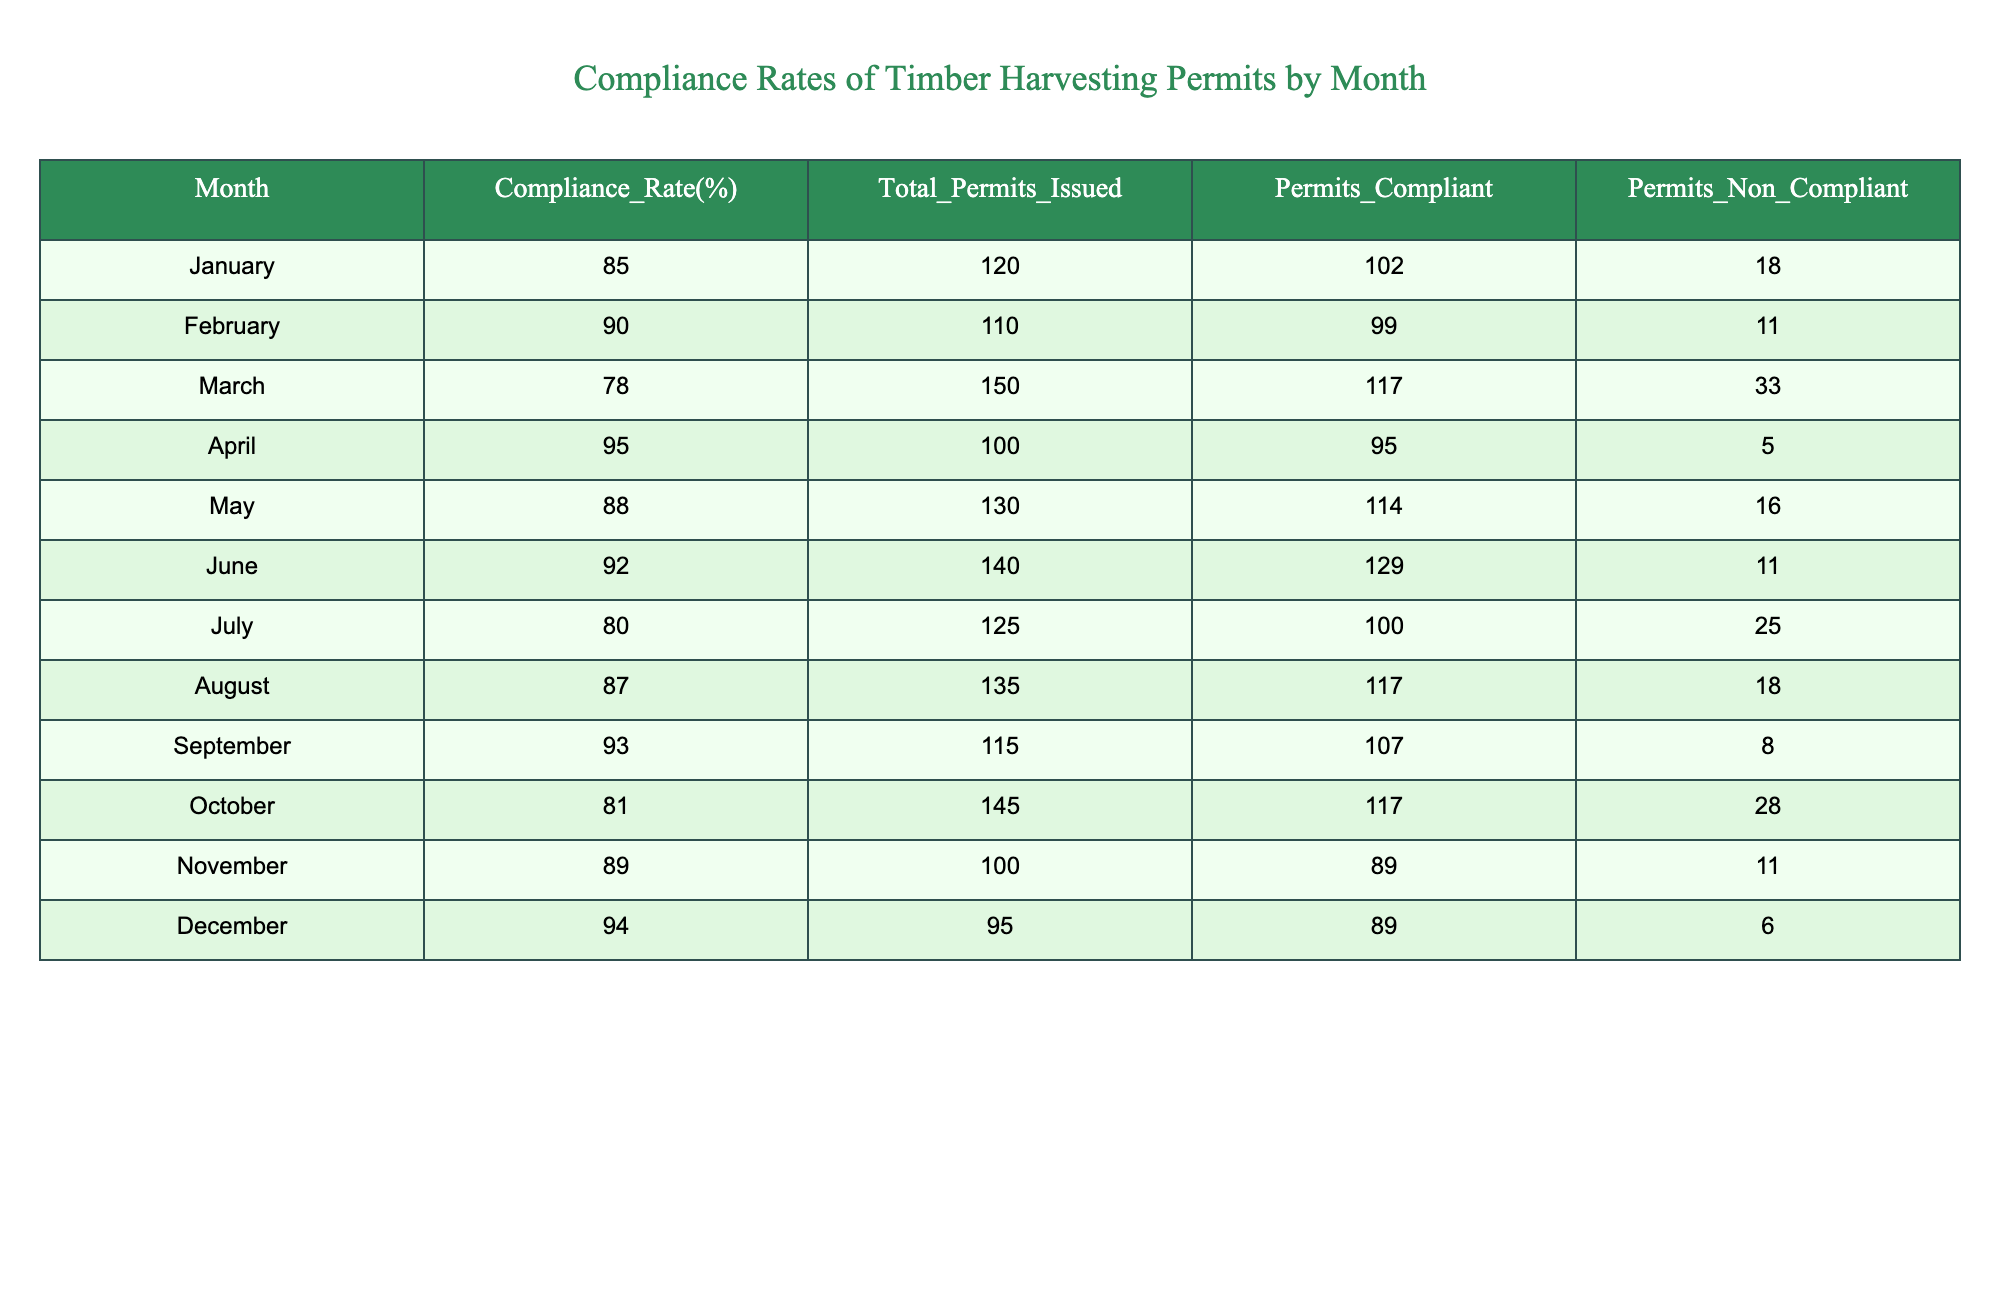What is the highest compliance rate recorded in the table? The compliance rates are listed in the second column, and by checking each month's compliance rate, April has the highest rate at 95%.
Answer: 95% In which month was the lowest number of permits compliant? Looking at the "Permits_Compliant" column, March has the lowest number with 117 permits compliant.
Answer: March What is the average compliance rate for the second half of the year (July to December)? To calculate the average, sum the compliance rates from July (80), August (87), September (93), October (81), November (89), and December (94), which equals 524. Dividing by 6 months gives an average of 87.33.
Answer: 87.33 Did any month have more non-compliant permits than compliant permits? By reviewing the "Permits_Compliant" and "Permits_Non_Compliant" columns, July shows 100 compliant versus 25 non-compliant, which means all months have more compliant permits than non-compliant. Therefore, the answer is no.
Answer: No Which month had the most total permits issued? The "Total_Permits_Issued" column shows that October had the most total permits with a count of 145 permits issued.
Answer: October How many total permits were compliant across all months? Adding the compliant permits from each month yields: 102 (January) + 99 (February) + 117 (March) + 95 (April) + 114 (May) + 129 (June) + 100 (July) + 117 (August) + 107 (September) + 117 (October) + 89 (November) + 89 (December) = 1,458 compliant permits in total.
Answer: 1458 What percentage of permits were non-compliant in March? Non-compliant permits in March are 33, and total permits issued are 150. The non-compliant percentage is (33/150) * 100 = 22%.
Answer: 22% Which month had the largest difference between compliant and non-compliant permits? Looking at the difference between "Permits_Compliant" and "Permits_Non_Compliant" for each month, March shows the largest difference: 117 compliant - 33 non-compliant = 84.
Answer: March 